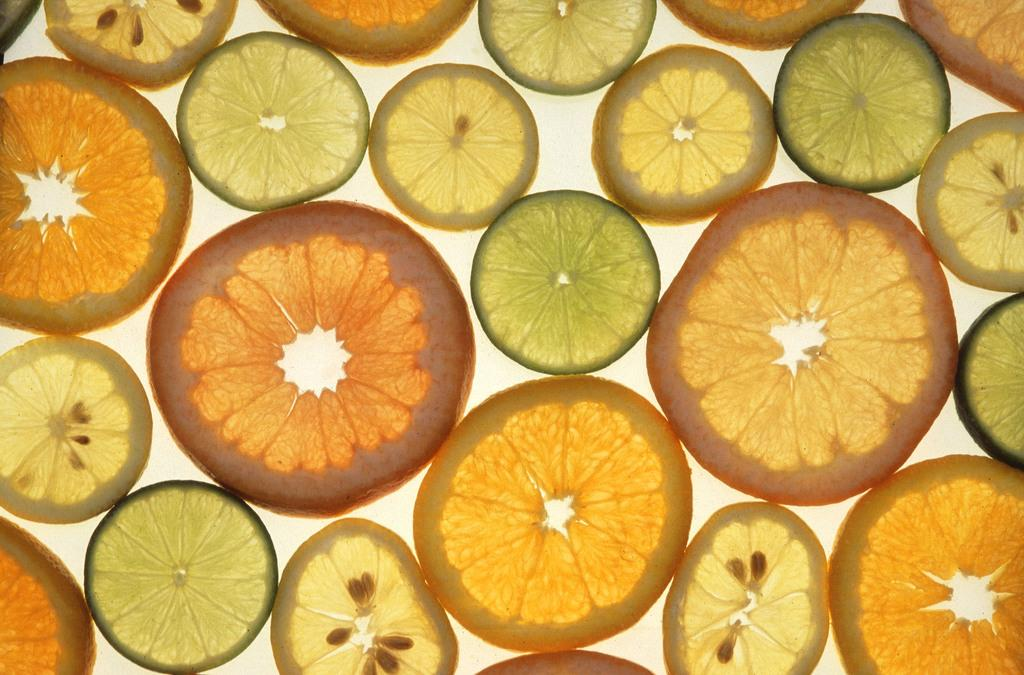What type of fruit pieces can be seen in the image? There are orange pieces and lemon pieces in the image. What color are the orange pieces? The orange pieces are orange in color. What color are the lemon pieces? The lemon pieces are green in color. What is the background color of the image? The background of the image is white. How many houses can be seen in the image? There are no houses present in the image; it features orange and lemon pieces with a white background. What type of ghost is visible in the image? There is no ghost present in the image; it features orange and lemon pieces with a white background. 